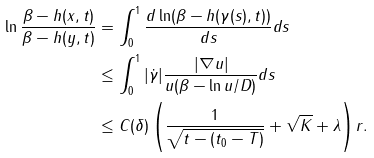Convert formula to latex. <formula><loc_0><loc_0><loc_500><loc_500>\ln \frac { \beta - h ( x , t ) } { \beta - h ( y , t ) } & = \int _ { 0 } ^ { 1 } \frac { d \ln ( \beta - h ( \gamma ( s ) , t ) ) } { d s } d s \\ & \leq \int _ { 0 } ^ { 1 } | \dot { \gamma } | \frac { | \nabla u | } { u ( \beta - \ln u / D ) } d s \\ & \leq C ( \delta ) \left ( \frac { 1 } { \sqrt { t - ( t _ { 0 } - T ) } } + \sqrt { K } + \lambda \right ) r .</formula> 